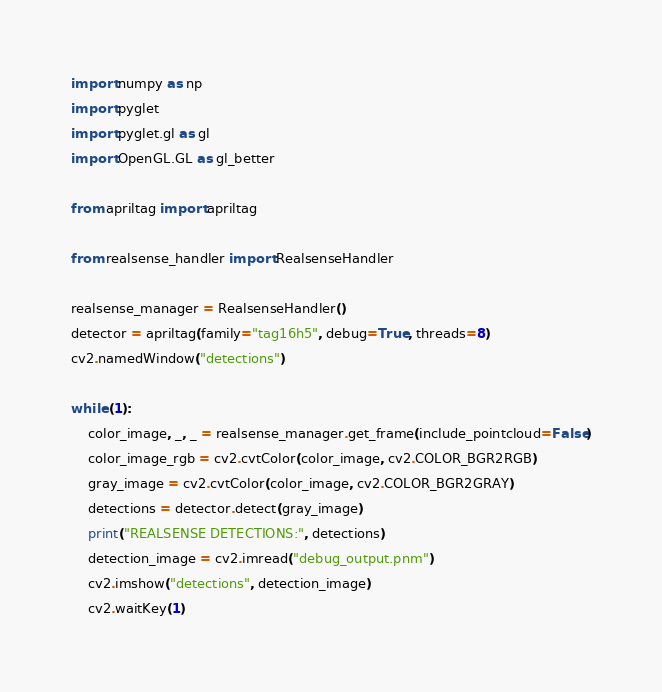<code> <loc_0><loc_0><loc_500><loc_500><_Python_>import numpy as np
import pyglet
import pyglet.gl as gl
import OpenGL.GL as gl_better

from apriltag import apriltag

from realsense_handler import RealsenseHandler

realsense_manager = RealsenseHandler()
detector = apriltag(family="tag16h5", debug=True, threads=8)
cv2.namedWindow("detections")

while (1):
    color_image, _, _ = realsense_manager.get_frame(include_pointcloud=False)
    color_image_rgb = cv2.cvtColor(color_image, cv2.COLOR_BGR2RGB)
    gray_image = cv2.cvtColor(color_image, cv2.COLOR_BGR2GRAY)
    detections = detector.detect(gray_image)
    print("REALSENSE DETECTIONS:", detections)
    detection_image = cv2.imread("debug_output.pnm")
    cv2.imshow("detections", detection_image)
    cv2.waitKey(1)
</code> 